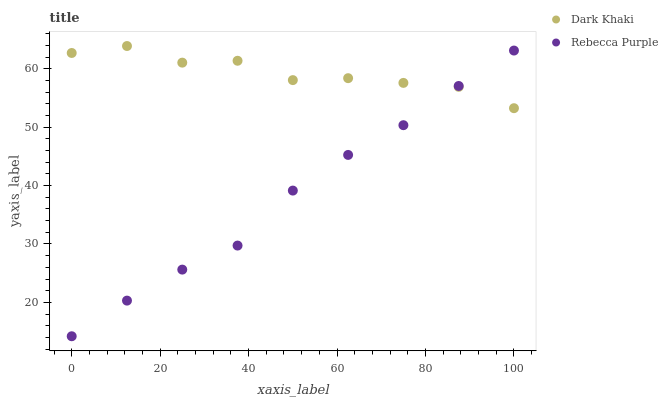Does Rebecca Purple have the minimum area under the curve?
Answer yes or no. Yes. Does Dark Khaki have the maximum area under the curve?
Answer yes or no. Yes. Does Rebecca Purple have the maximum area under the curve?
Answer yes or no. No. Is Rebecca Purple the smoothest?
Answer yes or no. Yes. Is Dark Khaki the roughest?
Answer yes or no. Yes. Is Rebecca Purple the roughest?
Answer yes or no. No. Does Rebecca Purple have the lowest value?
Answer yes or no. Yes. Does Dark Khaki have the highest value?
Answer yes or no. Yes. Does Rebecca Purple have the highest value?
Answer yes or no. No. Does Rebecca Purple intersect Dark Khaki?
Answer yes or no. Yes. Is Rebecca Purple less than Dark Khaki?
Answer yes or no. No. Is Rebecca Purple greater than Dark Khaki?
Answer yes or no. No. 